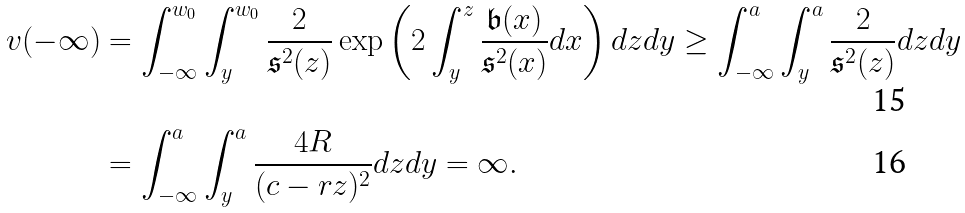Convert formula to latex. <formula><loc_0><loc_0><loc_500><loc_500>v ( - \infty ) & = \int ^ { w _ { 0 } } _ { - \infty } \int ^ { w _ { 0 } } _ { y } \frac { 2 } { \mathfrak { s } ^ { 2 } ( z ) } \exp \left ( 2 \int ^ { z } _ { y } \frac { \mathfrak { b } ( x ) } { \mathfrak { s } ^ { 2 } ( x ) } d x \right ) d z d y \geq \int ^ { a } _ { - \infty } \int ^ { a } _ { y } \frac { 2 } { \mathfrak { s } ^ { 2 } ( z ) } d z d y \\ & = \int ^ { a } _ { - \infty } \int ^ { a } _ { y } \frac { 4 R } { ( c - r z ) ^ { 2 } } d z d y = \infty .</formula> 